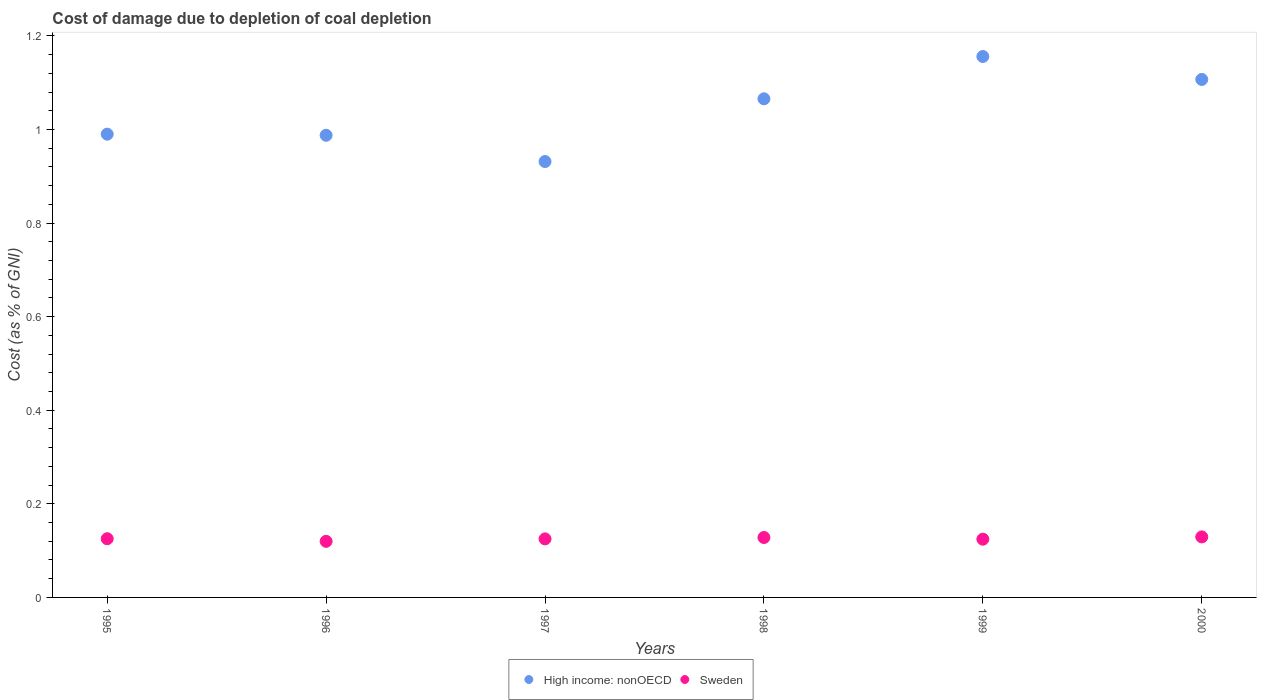What is the cost of damage caused due to coal depletion in Sweden in 1995?
Keep it short and to the point. 0.13. Across all years, what is the maximum cost of damage caused due to coal depletion in High income: nonOECD?
Make the answer very short. 1.16. Across all years, what is the minimum cost of damage caused due to coal depletion in Sweden?
Provide a succinct answer. 0.12. What is the total cost of damage caused due to coal depletion in Sweden in the graph?
Your response must be concise. 0.75. What is the difference between the cost of damage caused due to coal depletion in High income: nonOECD in 1995 and that in 1996?
Give a very brief answer. 0. What is the difference between the cost of damage caused due to coal depletion in Sweden in 1999 and the cost of damage caused due to coal depletion in High income: nonOECD in 1996?
Make the answer very short. -0.86. What is the average cost of damage caused due to coal depletion in High income: nonOECD per year?
Give a very brief answer. 1.04. In the year 1997, what is the difference between the cost of damage caused due to coal depletion in High income: nonOECD and cost of damage caused due to coal depletion in Sweden?
Ensure brevity in your answer.  0.81. In how many years, is the cost of damage caused due to coal depletion in High income: nonOECD greater than 0.6000000000000001 %?
Offer a very short reply. 6. What is the ratio of the cost of damage caused due to coal depletion in High income: nonOECD in 1999 to that in 2000?
Your answer should be compact. 1.04. Is the cost of damage caused due to coal depletion in Sweden in 1995 less than that in 1999?
Your answer should be very brief. No. What is the difference between the highest and the second highest cost of damage caused due to coal depletion in High income: nonOECD?
Provide a succinct answer. 0.05. What is the difference between the highest and the lowest cost of damage caused due to coal depletion in High income: nonOECD?
Ensure brevity in your answer.  0.22. In how many years, is the cost of damage caused due to coal depletion in Sweden greater than the average cost of damage caused due to coal depletion in Sweden taken over all years?
Your response must be concise. 3. Is the sum of the cost of damage caused due to coal depletion in High income: nonOECD in 1996 and 2000 greater than the maximum cost of damage caused due to coal depletion in Sweden across all years?
Offer a very short reply. Yes. Is the cost of damage caused due to coal depletion in High income: nonOECD strictly less than the cost of damage caused due to coal depletion in Sweden over the years?
Keep it short and to the point. No. How many years are there in the graph?
Offer a very short reply. 6. What is the difference between two consecutive major ticks on the Y-axis?
Offer a terse response. 0.2. Are the values on the major ticks of Y-axis written in scientific E-notation?
Your answer should be compact. No. Does the graph contain any zero values?
Make the answer very short. No. Does the graph contain grids?
Offer a terse response. No. What is the title of the graph?
Provide a short and direct response. Cost of damage due to depletion of coal depletion. What is the label or title of the Y-axis?
Provide a short and direct response. Cost (as % of GNI). What is the Cost (as % of GNI) in High income: nonOECD in 1995?
Ensure brevity in your answer.  0.99. What is the Cost (as % of GNI) in Sweden in 1995?
Keep it short and to the point. 0.13. What is the Cost (as % of GNI) in High income: nonOECD in 1996?
Offer a very short reply. 0.99. What is the Cost (as % of GNI) in Sweden in 1996?
Ensure brevity in your answer.  0.12. What is the Cost (as % of GNI) of High income: nonOECD in 1997?
Offer a very short reply. 0.93. What is the Cost (as % of GNI) in Sweden in 1997?
Your response must be concise. 0.13. What is the Cost (as % of GNI) in High income: nonOECD in 1998?
Provide a succinct answer. 1.07. What is the Cost (as % of GNI) in Sweden in 1998?
Give a very brief answer. 0.13. What is the Cost (as % of GNI) of High income: nonOECD in 1999?
Your response must be concise. 1.16. What is the Cost (as % of GNI) of Sweden in 1999?
Provide a short and direct response. 0.12. What is the Cost (as % of GNI) of High income: nonOECD in 2000?
Offer a very short reply. 1.11. What is the Cost (as % of GNI) in Sweden in 2000?
Your response must be concise. 0.13. Across all years, what is the maximum Cost (as % of GNI) of High income: nonOECD?
Your answer should be very brief. 1.16. Across all years, what is the maximum Cost (as % of GNI) in Sweden?
Your answer should be very brief. 0.13. Across all years, what is the minimum Cost (as % of GNI) in High income: nonOECD?
Offer a terse response. 0.93. Across all years, what is the minimum Cost (as % of GNI) of Sweden?
Your response must be concise. 0.12. What is the total Cost (as % of GNI) of High income: nonOECD in the graph?
Make the answer very short. 6.24. What is the total Cost (as % of GNI) in Sweden in the graph?
Keep it short and to the point. 0.75. What is the difference between the Cost (as % of GNI) of High income: nonOECD in 1995 and that in 1996?
Ensure brevity in your answer.  0. What is the difference between the Cost (as % of GNI) of Sweden in 1995 and that in 1996?
Provide a short and direct response. 0.01. What is the difference between the Cost (as % of GNI) in High income: nonOECD in 1995 and that in 1997?
Your answer should be very brief. 0.06. What is the difference between the Cost (as % of GNI) of Sweden in 1995 and that in 1997?
Your answer should be compact. 0. What is the difference between the Cost (as % of GNI) of High income: nonOECD in 1995 and that in 1998?
Offer a very short reply. -0.08. What is the difference between the Cost (as % of GNI) of Sweden in 1995 and that in 1998?
Provide a succinct answer. -0. What is the difference between the Cost (as % of GNI) of High income: nonOECD in 1995 and that in 1999?
Provide a succinct answer. -0.17. What is the difference between the Cost (as % of GNI) in High income: nonOECD in 1995 and that in 2000?
Offer a very short reply. -0.12. What is the difference between the Cost (as % of GNI) in Sweden in 1995 and that in 2000?
Provide a short and direct response. -0. What is the difference between the Cost (as % of GNI) of High income: nonOECD in 1996 and that in 1997?
Make the answer very short. 0.06. What is the difference between the Cost (as % of GNI) of Sweden in 1996 and that in 1997?
Offer a terse response. -0.01. What is the difference between the Cost (as % of GNI) of High income: nonOECD in 1996 and that in 1998?
Provide a succinct answer. -0.08. What is the difference between the Cost (as % of GNI) of Sweden in 1996 and that in 1998?
Ensure brevity in your answer.  -0.01. What is the difference between the Cost (as % of GNI) of High income: nonOECD in 1996 and that in 1999?
Your answer should be compact. -0.17. What is the difference between the Cost (as % of GNI) of Sweden in 1996 and that in 1999?
Offer a terse response. -0. What is the difference between the Cost (as % of GNI) of High income: nonOECD in 1996 and that in 2000?
Your answer should be very brief. -0.12. What is the difference between the Cost (as % of GNI) of Sweden in 1996 and that in 2000?
Your answer should be very brief. -0.01. What is the difference between the Cost (as % of GNI) in High income: nonOECD in 1997 and that in 1998?
Offer a terse response. -0.13. What is the difference between the Cost (as % of GNI) in Sweden in 1997 and that in 1998?
Your answer should be compact. -0. What is the difference between the Cost (as % of GNI) of High income: nonOECD in 1997 and that in 1999?
Keep it short and to the point. -0.22. What is the difference between the Cost (as % of GNI) in Sweden in 1997 and that in 1999?
Provide a short and direct response. 0. What is the difference between the Cost (as % of GNI) in High income: nonOECD in 1997 and that in 2000?
Offer a terse response. -0.18. What is the difference between the Cost (as % of GNI) in Sweden in 1997 and that in 2000?
Make the answer very short. -0. What is the difference between the Cost (as % of GNI) in High income: nonOECD in 1998 and that in 1999?
Your answer should be compact. -0.09. What is the difference between the Cost (as % of GNI) of Sweden in 1998 and that in 1999?
Give a very brief answer. 0. What is the difference between the Cost (as % of GNI) in High income: nonOECD in 1998 and that in 2000?
Provide a succinct answer. -0.04. What is the difference between the Cost (as % of GNI) in Sweden in 1998 and that in 2000?
Keep it short and to the point. -0. What is the difference between the Cost (as % of GNI) in High income: nonOECD in 1999 and that in 2000?
Make the answer very short. 0.05. What is the difference between the Cost (as % of GNI) in Sweden in 1999 and that in 2000?
Make the answer very short. -0. What is the difference between the Cost (as % of GNI) of High income: nonOECD in 1995 and the Cost (as % of GNI) of Sweden in 1996?
Provide a short and direct response. 0.87. What is the difference between the Cost (as % of GNI) in High income: nonOECD in 1995 and the Cost (as % of GNI) in Sweden in 1997?
Give a very brief answer. 0.86. What is the difference between the Cost (as % of GNI) of High income: nonOECD in 1995 and the Cost (as % of GNI) of Sweden in 1998?
Your answer should be compact. 0.86. What is the difference between the Cost (as % of GNI) of High income: nonOECD in 1995 and the Cost (as % of GNI) of Sweden in 1999?
Ensure brevity in your answer.  0.87. What is the difference between the Cost (as % of GNI) in High income: nonOECD in 1995 and the Cost (as % of GNI) in Sweden in 2000?
Provide a succinct answer. 0.86. What is the difference between the Cost (as % of GNI) in High income: nonOECD in 1996 and the Cost (as % of GNI) in Sweden in 1997?
Offer a very short reply. 0.86. What is the difference between the Cost (as % of GNI) in High income: nonOECD in 1996 and the Cost (as % of GNI) in Sweden in 1998?
Your answer should be very brief. 0.86. What is the difference between the Cost (as % of GNI) of High income: nonOECD in 1996 and the Cost (as % of GNI) of Sweden in 1999?
Keep it short and to the point. 0.86. What is the difference between the Cost (as % of GNI) of High income: nonOECD in 1996 and the Cost (as % of GNI) of Sweden in 2000?
Make the answer very short. 0.86. What is the difference between the Cost (as % of GNI) of High income: nonOECD in 1997 and the Cost (as % of GNI) of Sweden in 1998?
Ensure brevity in your answer.  0.8. What is the difference between the Cost (as % of GNI) in High income: nonOECD in 1997 and the Cost (as % of GNI) in Sweden in 1999?
Your answer should be compact. 0.81. What is the difference between the Cost (as % of GNI) of High income: nonOECD in 1997 and the Cost (as % of GNI) of Sweden in 2000?
Give a very brief answer. 0.8. What is the difference between the Cost (as % of GNI) of High income: nonOECD in 1998 and the Cost (as % of GNI) of Sweden in 1999?
Offer a terse response. 0.94. What is the difference between the Cost (as % of GNI) of High income: nonOECD in 1998 and the Cost (as % of GNI) of Sweden in 2000?
Keep it short and to the point. 0.94. What is the difference between the Cost (as % of GNI) of High income: nonOECD in 1999 and the Cost (as % of GNI) of Sweden in 2000?
Provide a short and direct response. 1.03. What is the average Cost (as % of GNI) in High income: nonOECD per year?
Offer a very short reply. 1.04. What is the average Cost (as % of GNI) in Sweden per year?
Your answer should be very brief. 0.13. In the year 1995, what is the difference between the Cost (as % of GNI) in High income: nonOECD and Cost (as % of GNI) in Sweden?
Your response must be concise. 0.86. In the year 1996, what is the difference between the Cost (as % of GNI) in High income: nonOECD and Cost (as % of GNI) in Sweden?
Ensure brevity in your answer.  0.87. In the year 1997, what is the difference between the Cost (as % of GNI) of High income: nonOECD and Cost (as % of GNI) of Sweden?
Offer a terse response. 0.81. In the year 1998, what is the difference between the Cost (as % of GNI) of High income: nonOECD and Cost (as % of GNI) of Sweden?
Make the answer very short. 0.94. In the year 1999, what is the difference between the Cost (as % of GNI) in High income: nonOECD and Cost (as % of GNI) in Sweden?
Your answer should be very brief. 1.03. In the year 2000, what is the difference between the Cost (as % of GNI) in High income: nonOECD and Cost (as % of GNI) in Sweden?
Make the answer very short. 0.98. What is the ratio of the Cost (as % of GNI) in High income: nonOECD in 1995 to that in 1996?
Keep it short and to the point. 1. What is the ratio of the Cost (as % of GNI) in Sweden in 1995 to that in 1996?
Your answer should be very brief. 1.05. What is the ratio of the Cost (as % of GNI) in High income: nonOECD in 1995 to that in 1997?
Your response must be concise. 1.06. What is the ratio of the Cost (as % of GNI) of Sweden in 1995 to that in 1997?
Offer a terse response. 1. What is the ratio of the Cost (as % of GNI) of High income: nonOECD in 1995 to that in 1998?
Offer a terse response. 0.93. What is the ratio of the Cost (as % of GNI) of Sweden in 1995 to that in 1998?
Your response must be concise. 0.98. What is the ratio of the Cost (as % of GNI) of High income: nonOECD in 1995 to that in 1999?
Offer a terse response. 0.86. What is the ratio of the Cost (as % of GNI) in Sweden in 1995 to that in 1999?
Make the answer very short. 1.01. What is the ratio of the Cost (as % of GNI) in High income: nonOECD in 1995 to that in 2000?
Your answer should be very brief. 0.89. What is the ratio of the Cost (as % of GNI) of Sweden in 1995 to that in 2000?
Make the answer very short. 0.97. What is the ratio of the Cost (as % of GNI) in High income: nonOECD in 1996 to that in 1997?
Your answer should be compact. 1.06. What is the ratio of the Cost (as % of GNI) of Sweden in 1996 to that in 1997?
Ensure brevity in your answer.  0.96. What is the ratio of the Cost (as % of GNI) of High income: nonOECD in 1996 to that in 1998?
Your answer should be very brief. 0.93. What is the ratio of the Cost (as % of GNI) of Sweden in 1996 to that in 1998?
Give a very brief answer. 0.94. What is the ratio of the Cost (as % of GNI) of High income: nonOECD in 1996 to that in 1999?
Provide a short and direct response. 0.85. What is the ratio of the Cost (as % of GNI) of High income: nonOECD in 1996 to that in 2000?
Offer a very short reply. 0.89. What is the ratio of the Cost (as % of GNI) in Sweden in 1996 to that in 2000?
Your response must be concise. 0.93. What is the ratio of the Cost (as % of GNI) of High income: nonOECD in 1997 to that in 1998?
Offer a terse response. 0.87. What is the ratio of the Cost (as % of GNI) in Sweden in 1997 to that in 1998?
Offer a terse response. 0.98. What is the ratio of the Cost (as % of GNI) of High income: nonOECD in 1997 to that in 1999?
Provide a succinct answer. 0.81. What is the ratio of the Cost (as % of GNI) in High income: nonOECD in 1997 to that in 2000?
Your answer should be very brief. 0.84. What is the ratio of the Cost (as % of GNI) of Sweden in 1997 to that in 2000?
Your answer should be very brief. 0.97. What is the ratio of the Cost (as % of GNI) in High income: nonOECD in 1998 to that in 1999?
Your response must be concise. 0.92. What is the ratio of the Cost (as % of GNI) of Sweden in 1998 to that in 1999?
Offer a very short reply. 1.03. What is the ratio of the Cost (as % of GNI) of High income: nonOECD in 1998 to that in 2000?
Ensure brevity in your answer.  0.96. What is the ratio of the Cost (as % of GNI) of Sweden in 1998 to that in 2000?
Keep it short and to the point. 0.99. What is the ratio of the Cost (as % of GNI) of High income: nonOECD in 1999 to that in 2000?
Offer a terse response. 1.04. What is the ratio of the Cost (as % of GNI) in Sweden in 1999 to that in 2000?
Keep it short and to the point. 0.96. What is the difference between the highest and the second highest Cost (as % of GNI) in High income: nonOECD?
Offer a terse response. 0.05. What is the difference between the highest and the second highest Cost (as % of GNI) in Sweden?
Give a very brief answer. 0. What is the difference between the highest and the lowest Cost (as % of GNI) in High income: nonOECD?
Ensure brevity in your answer.  0.22. What is the difference between the highest and the lowest Cost (as % of GNI) in Sweden?
Provide a short and direct response. 0.01. 